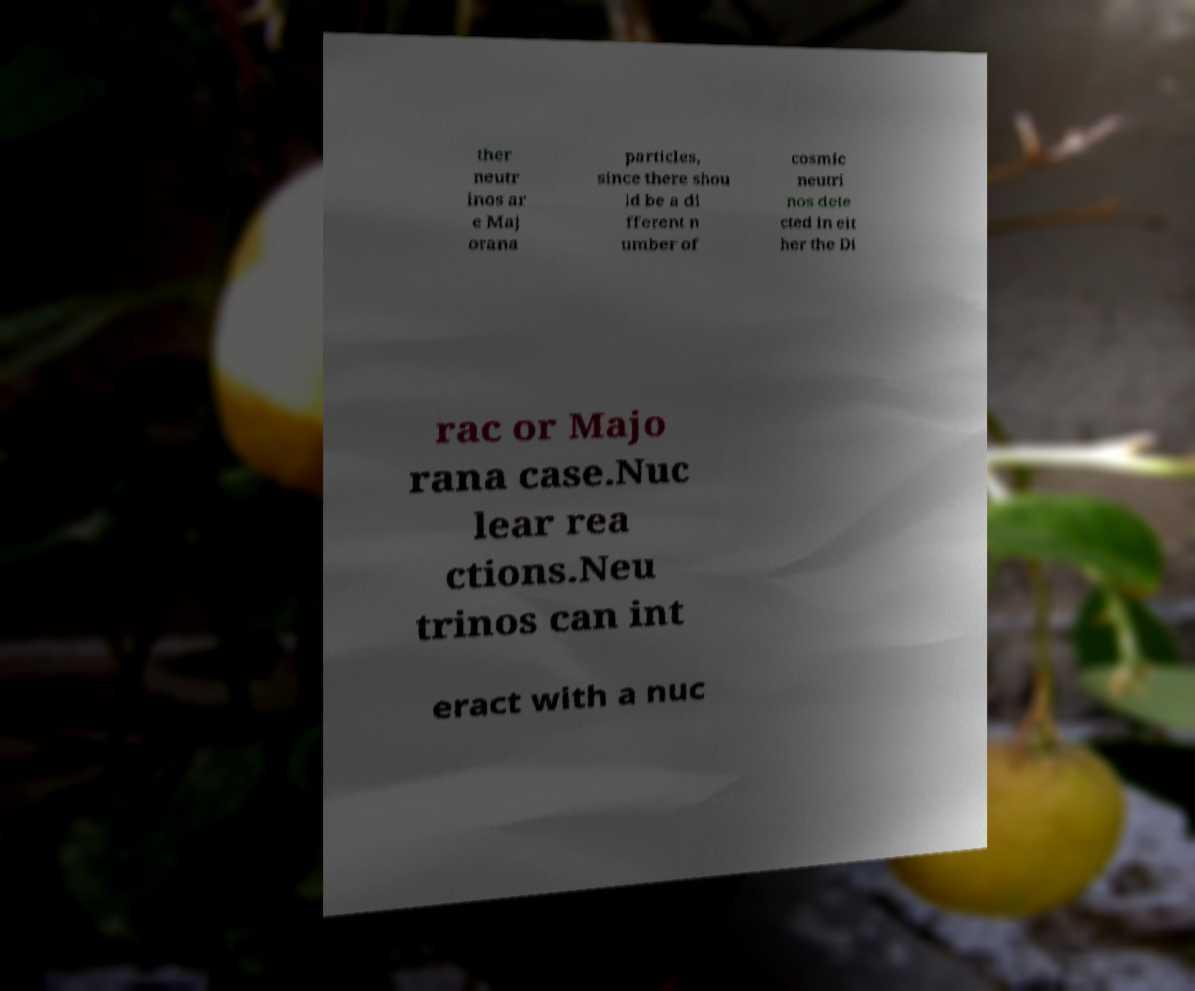Can you read and provide the text displayed in the image?This photo seems to have some interesting text. Can you extract and type it out for me? ther neutr inos ar e Maj orana particles, since there shou ld be a di fferent n umber of cosmic neutri nos dete cted in eit her the Di rac or Majo rana case.Nuc lear rea ctions.Neu trinos can int eract with a nuc 